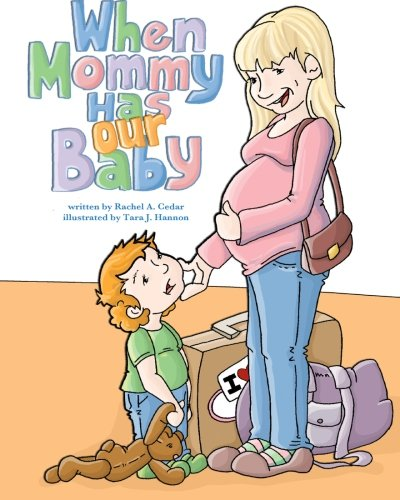What emotions do the facial expressions convey in this illustration? The facial expressions in the illustration convey feelings of happiness and anticipation. The mother's gentle smile and the child's wide-eyed, inquisitive look add to a scene filled with positive emotions. 